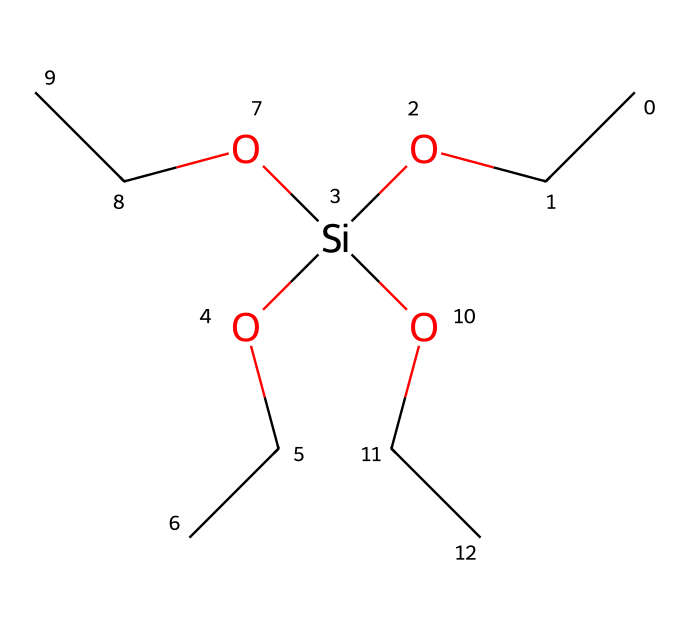What is the molecular formula of the compound represented by this SMILES? The SMILES notation indicates that there are one silicon atom and four ethoxy groups connected; each ethoxy group brings two carbons and five hydrogens along with one oxygen connected to silicon. Thus, the molecular formula reflects those counts.
Answer: Si(C2H5O)4 How many oxygen atoms are present in the molecule? The given SMILES shows that each of the four ethoxy (OCC) groups contains one oxygen atom, and there is an additional silicon-oxygen bond, totaling five oxygen atoms in the molecule.
Answer: five What is the hybridization of the silicon atom in tetraethoxysilane? Silicon in tetraethoxysilane forms four sigma bonds with the oxygen atoms in the ethoxy groups; thus, it undergoes sp3 hybridization. This is determined by counting the number of sigma bonds and estimating the geometry.
Answer: sp3 How many carbon atoms are present in the structure of this compound? Each ethoxy group (OCC) has two carbon atoms and there are four such groups in the structure, leading to a total of eight carbon atoms connected to the silicon.
Answer: eight Why is tetraethoxysilane commonly used as a precursor in sol-gel processes? Tetraethoxysilane contains reactive silicon and oxygen functional groups that can undergo hydrolysis and condensation reactions, making it suitable for forming silica networks in sol-gel chemistry. This functional characteristic serves as a basis in the synthesis of silica-based materials.
Answer: reactive functional groups What type of chemical compound is tetraethoxysilane classified as? Based on its structure and the presence of silicon atoms bonded with alkoxy groups, tetraethoxysilane is classified as an organosilicon compound, specifically a silane.
Answer: organosilicon 